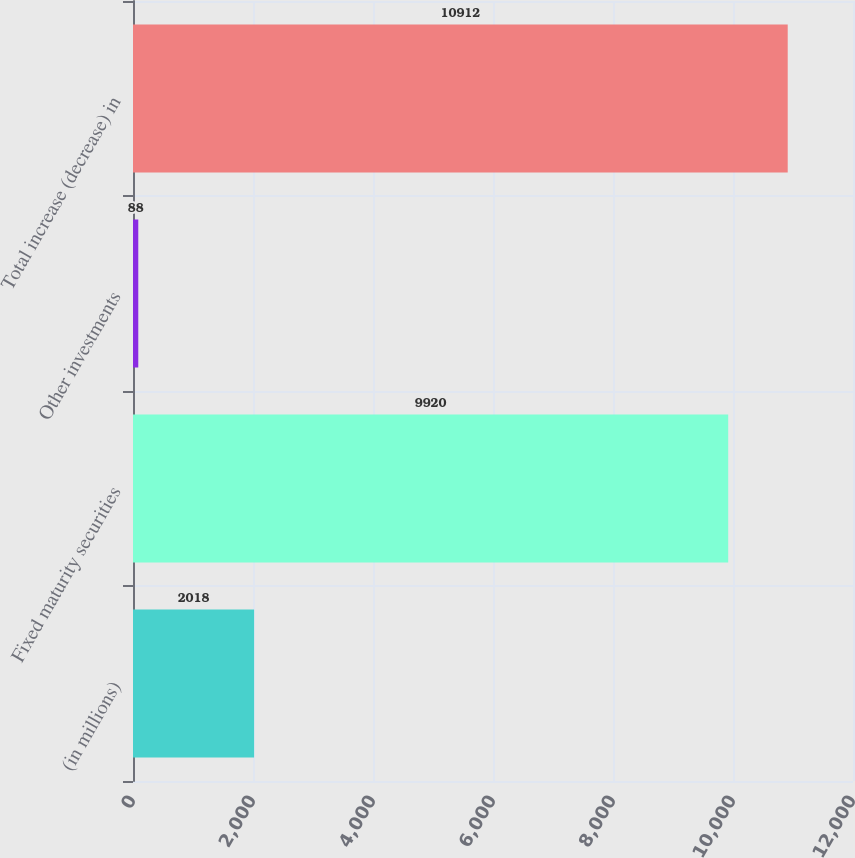Convert chart. <chart><loc_0><loc_0><loc_500><loc_500><bar_chart><fcel>(in millions)<fcel>Fixed maturity securities<fcel>Other investments<fcel>Total increase (decrease) in<nl><fcel>2018<fcel>9920<fcel>88<fcel>10912<nl></chart> 